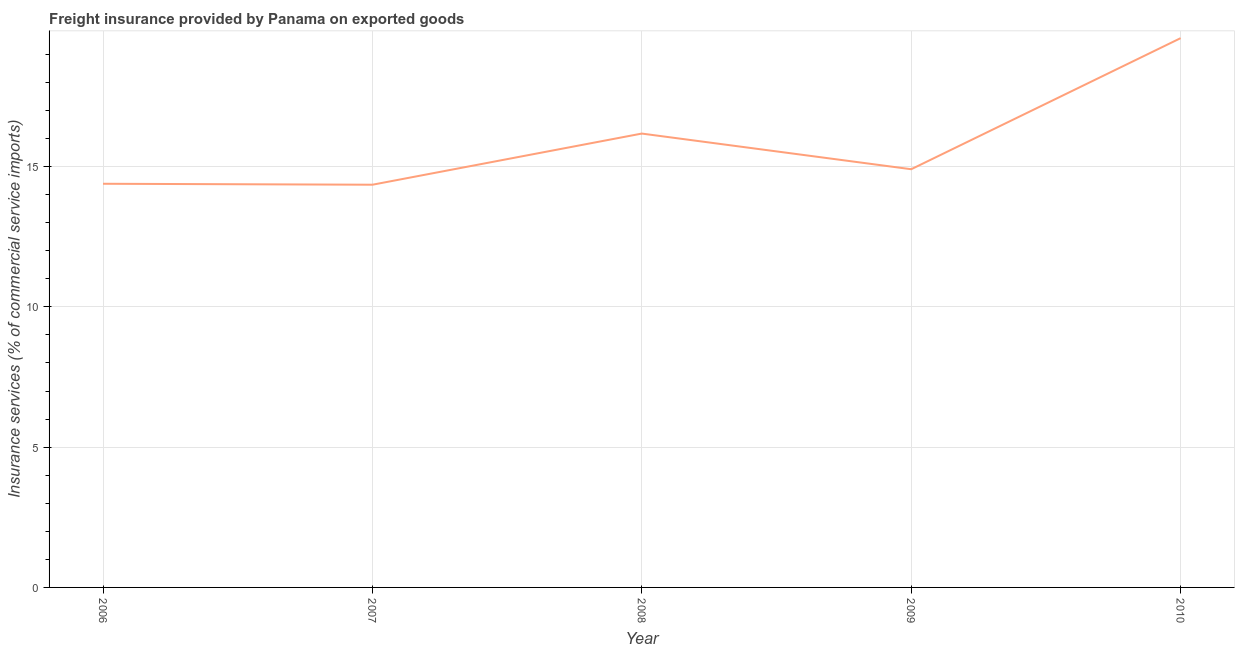What is the freight insurance in 2007?
Your answer should be very brief. 14.35. Across all years, what is the maximum freight insurance?
Keep it short and to the point. 19.58. Across all years, what is the minimum freight insurance?
Your response must be concise. 14.35. In which year was the freight insurance maximum?
Provide a short and direct response. 2010. What is the sum of the freight insurance?
Offer a terse response. 79.4. What is the difference between the freight insurance in 2006 and 2007?
Give a very brief answer. 0.03. What is the average freight insurance per year?
Make the answer very short. 15.88. What is the median freight insurance?
Keep it short and to the point. 14.9. In how many years, is the freight insurance greater than 6 %?
Your answer should be very brief. 5. Do a majority of the years between 2010 and 2008 (inclusive) have freight insurance greater than 7 %?
Ensure brevity in your answer.  No. What is the ratio of the freight insurance in 2006 to that in 2007?
Offer a terse response. 1. Is the difference between the freight insurance in 2007 and 2010 greater than the difference between any two years?
Provide a short and direct response. Yes. What is the difference between the highest and the second highest freight insurance?
Ensure brevity in your answer.  3.4. Is the sum of the freight insurance in 2006 and 2009 greater than the maximum freight insurance across all years?
Ensure brevity in your answer.  Yes. What is the difference between the highest and the lowest freight insurance?
Keep it short and to the point. 5.22. In how many years, is the freight insurance greater than the average freight insurance taken over all years?
Your response must be concise. 2. Does the freight insurance monotonically increase over the years?
Provide a succinct answer. No. How many lines are there?
Keep it short and to the point. 1. How many years are there in the graph?
Your response must be concise. 5. What is the difference between two consecutive major ticks on the Y-axis?
Provide a succinct answer. 5. What is the title of the graph?
Your answer should be very brief. Freight insurance provided by Panama on exported goods . What is the label or title of the Y-axis?
Provide a short and direct response. Insurance services (% of commercial service imports). What is the Insurance services (% of commercial service imports) in 2006?
Give a very brief answer. 14.39. What is the Insurance services (% of commercial service imports) in 2007?
Offer a very short reply. 14.35. What is the Insurance services (% of commercial service imports) of 2008?
Offer a terse response. 16.18. What is the Insurance services (% of commercial service imports) in 2009?
Give a very brief answer. 14.9. What is the Insurance services (% of commercial service imports) of 2010?
Your answer should be very brief. 19.58. What is the difference between the Insurance services (% of commercial service imports) in 2006 and 2007?
Offer a terse response. 0.03. What is the difference between the Insurance services (% of commercial service imports) in 2006 and 2008?
Provide a succinct answer. -1.79. What is the difference between the Insurance services (% of commercial service imports) in 2006 and 2009?
Offer a very short reply. -0.52. What is the difference between the Insurance services (% of commercial service imports) in 2006 and 2010?
Make the answer very short. -5.19. What is the difference between the Insurance services (% of commercial service imports) in 2007 and 2008?
Ensure brevity in your answer.  -1.82. What is the difference between the Insurance services (% of commercial service imports) in 2007 and 2009?
Give a very brief answer. -0.55. What is the difference between the Insurance services (% of commercial service imports) in 2007 and 2010?
Offer a very short reply. -5.22. What is the difference between the Insurance services (% of commercial service imports) in 2008 and 2009?
Ensure brevity in your answer.  1.27. What is the difference between the Insurance services (% of commercial service imports) in 2008 and 2010?
Your answer should be compact. -3.4. What is the difference between the Insurance services (% of commercial service imports) in 2009 and 2010?
Provide a succinct answer. -4.67. What is the ratio of the Insurance services (% of commercial service imports) in 2006 to that in 2007?
Provide a short and direct response. 1. What is the ratio of the Insurance services (% of commercial service imports) in 2006 to that in 2008?
Make the answer very short. 0.89. What is the ratio of the Insurance services (% of commercial service imports) in 2006 to that in 2010?
Provide a succinct answer. 0.73. What is the ratio of the Insurance services (% of commercial service imports) in 2007 to that in 2008?
Your response must be concise. 0.89. What is the ratio of the Insurance services (% of commercial service imports) in 2007 to that in 2010?
Ensure brevity in your answer.  0.73. What is the ratio of the Insurance services (% of commercial service imports) in 2008 to that in 2009?
Provide a succinct answer. 1.08. What is the ratio of the Insurance services (% of commercial service imports) in 2008 to that in 2010?
Offer a very short reply. 0.83. What is the ratio of the Insurance services (% of commercial service imports) in 2009 to that in 2010?
Keep it short and to the point. 0.76. 